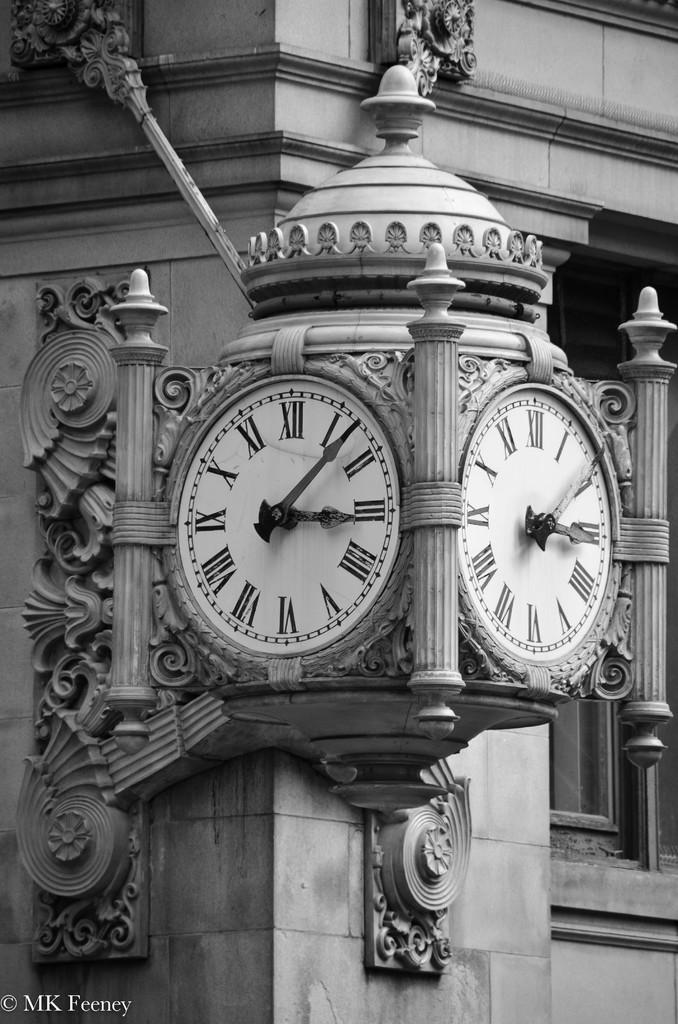What time is on the clock?
Your answer should be very brief. 3:07. What number is the small hand pointing to?
Keep it short and to the point. 3. 